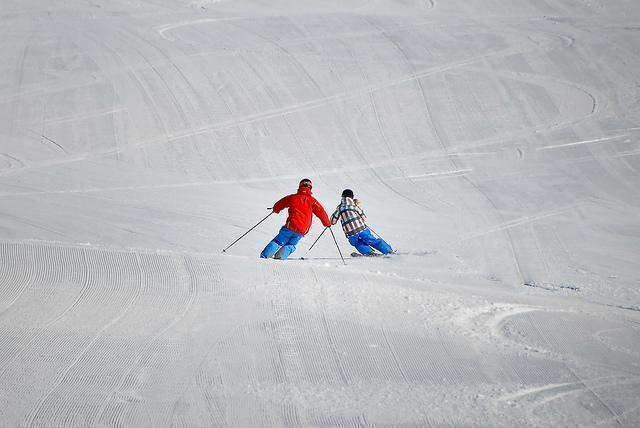What type of action are the people taking?
Select the correct answer and articulate reasoning with the following format: 'Answer: answer
Rationale: rationale.'
Options: Retreat, ascend, descent, attack. Answer: descent.
Rationale: The people are skiing and, since it's impossible to ski up, they are skiing downhill or descending. 